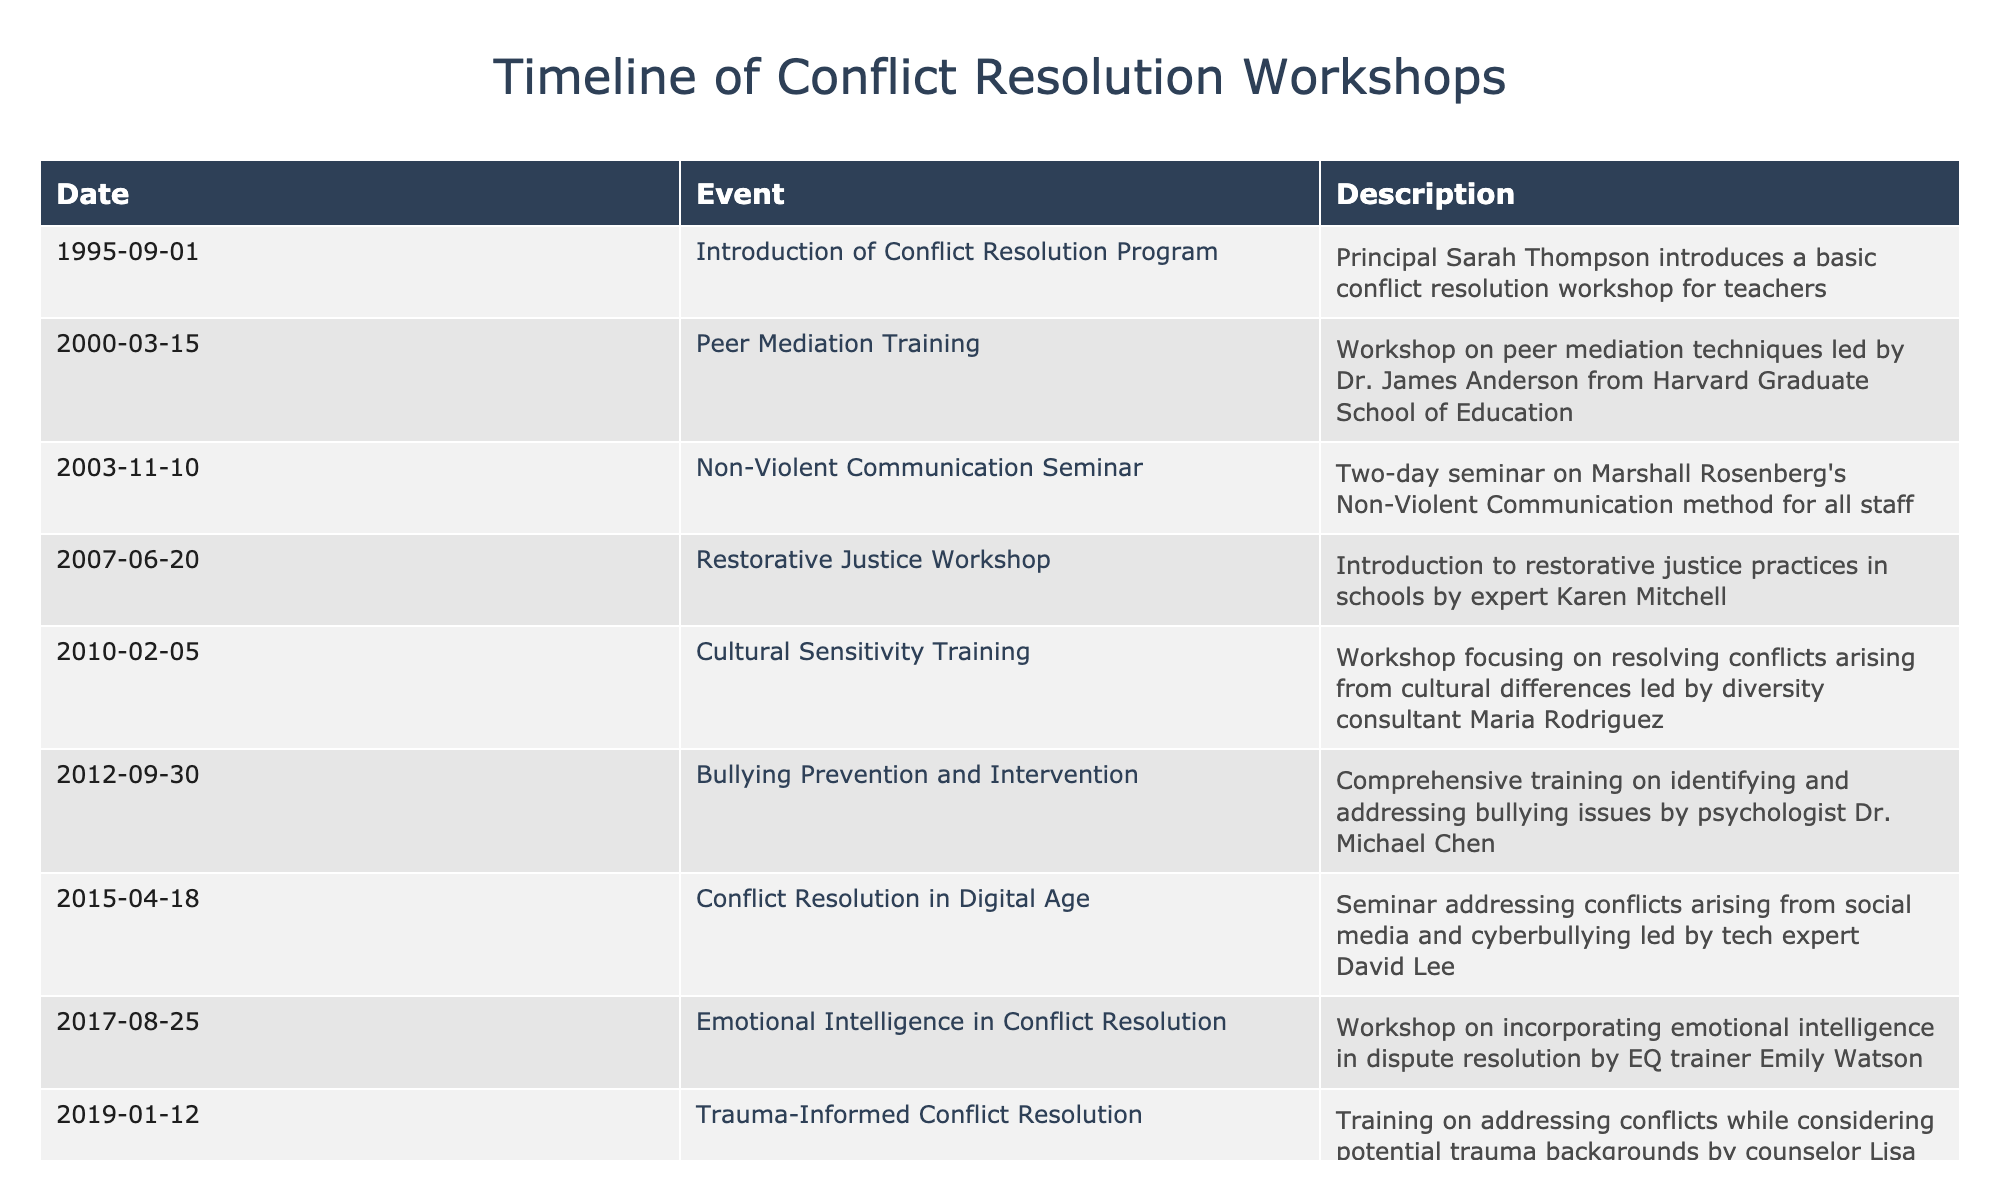What was the first conflict resolution workshop introduced for teachers? The first workshop listed in the table is dated September 1, 1995, which is the "Introduction of Conflict Resolution Program" led by Principal Sarah Thompson.
Answer: Introduction of Conflict Resolution Program How many workshops were conducted before 2010? By counting the entries in the table, the workshops before 2010 are from 1995 to 2007, totaling six workshops.
Answer: 6 Was there any workshop that specifically focused on bullying prevention? The table indicates a workshop called "Bullying Prevention and Intervention," which was conducted on September 30, 2012. Therefore, the answer is yes.
Answer: Yes What is the latest workshop focused on virtual conflict resolution environments? The most recent workshop addressing virtual conflict resolution strategies is dated June 30, 2021, titled "Virtual Conflict Resolution Strategies."
Answer: Virtual Conflict Resolution Strategies Which workshop was focused on cultural differences and conflict resolution? The workshop titled "Cultural Sensitivity Training," which took place on February 5, 2010, addresses conflicts arising from cultural differences.
Answer: Cultural Sensitivity Training How many years passed between the introduction of the conflict resolution program and the emotional intelligence workshop? The conflict resolution program started in 1995, and the emotional intelligence workshop occurred on August 25, 2017. From 1995 to 2017 is 22 years.
Answer: 22 years Did any workshops address issues arising from social media? Yes, the workshop titled "Conflict Resolution in Digital Age" held on April 18, 2015, specifically addresses conflicts arising from social media and cyberbullying.
Answer: Yes Which expert conducted the peer mediation training workshop and when? The peer mediation training was led by Dr. James Anderson from Harvard Graduate School of Education on March 15, 2000.
Answer: Dr. James Anderson on March 15, 2000 What percentage of the listed workshops focus on emotional and psychological aspects of conflict resolution? Out of the total ten workshops listed, four specifically focus on emotional or psychological aspects: Non-Violent Communication, Restorative Justice, Trauma-Informed Conflict Resolution, and Emotional Intelligence in Conflict Resolution. This makes 40%.
Answer: 40% 